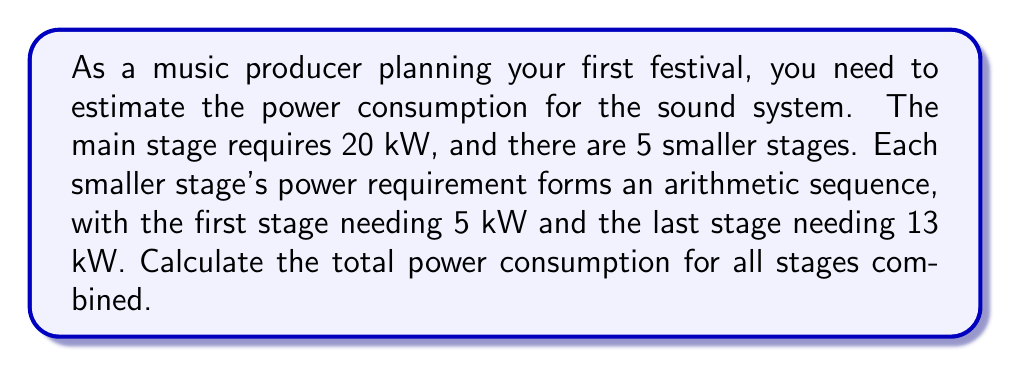Give your solution to this math problem. Let's approach this step-by-step:

1) For the main stage, we already know it requires 20 kW.

2) For the 5 smaller stages, we need to find the arithmetic sequence and sum it up.

3) In an arithmetic sequence, we have:
   $a_1 = 5$ (first term)
   $a_5 = 13$ (last term)
   $n = 5$ (number of terms)

4) To find the common difference (d), we can use the formula:
   $$a_n = a_1 + (n-1)d$$
   $$13 = 5 + (5-1)d$$
   $$13 = 5 + 4d$$
   $$8 = 4d$$
   $$d = 2$$

5) Now that we have the first term $(a_1 = 5)$, the number of terms $(n = 5)$, and the common difference $(d = 2)$, we can use the arithmetic sequence sum formula:

   $$S_n = \frac{n}{2}(a_1 + a_n) = \frac{n}{2}(2a_1 + (n-1)d)$$

6) Plugging in our values:
   $$S_5 = \frac{5}{2}(2(5) + (5-1)(2))$$
   $$S_5 = \frac{5}{2}(10 + 8)$$
   $$S_5 = \frac{5}{2}(18)$$
   $$S_5 = 45$$

7) So the sum of power requirements for the 5 smaller stages is 45 kW.

8) Total power consumption = Main stage + Sum of smaller stages
   $$Total = 20 + 45 = 65 kW$$
Answer: 65 kW 